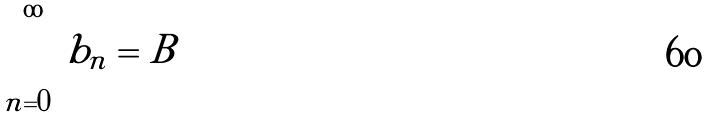<formula> <loc_0><loc_0><loc_500><loc_500>\sum _ { n = 0 } ^ { \infty } b _ { n } = B</formula> 